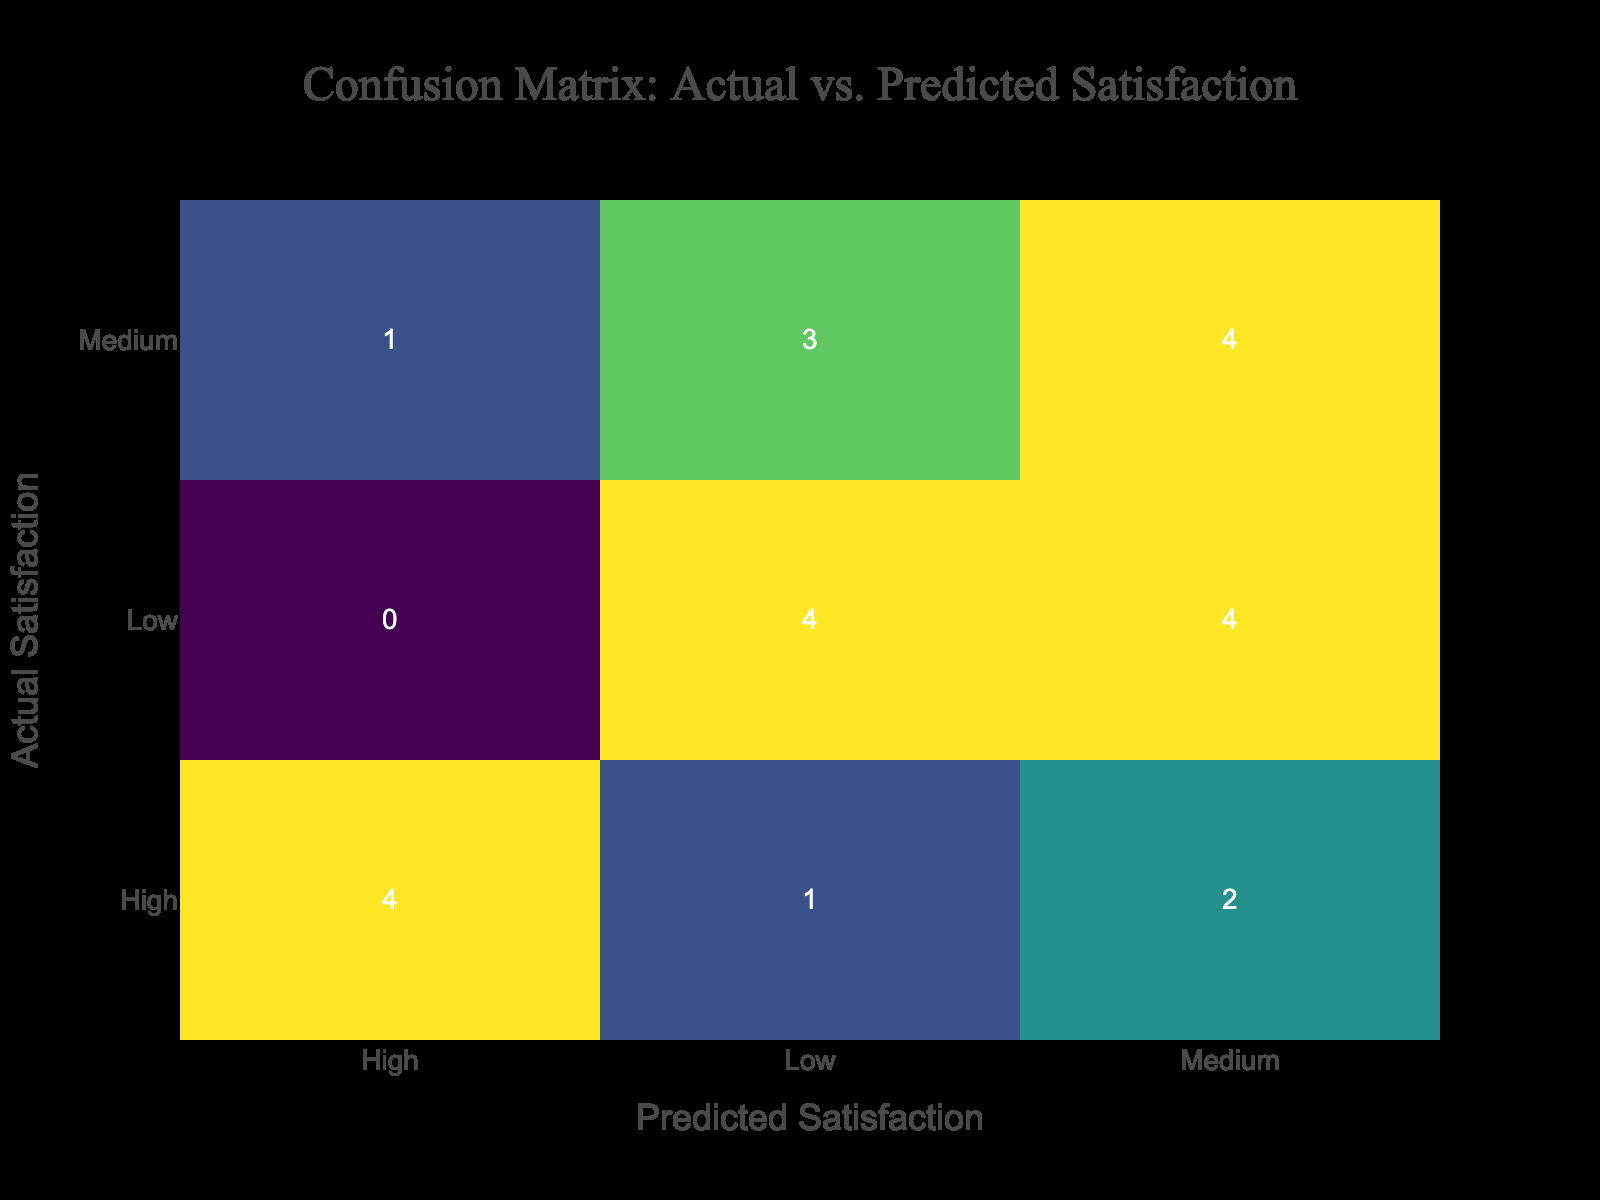What is the total number of instances where the actual satisfaction was low for the spa service? There are four recorded instances under the Spa service where the actual satisfaction was low: (Low, Low) and (Low, Medium) which appear once each in the table. Hence the total count is 2.
Answer: 2 What is the predicted satisfaction level for the majority of actual high satisfaction ratings in the concierge service? In the concierge service, out of the six instances with actual high satisfaction, four have a predicted satisfaction level of high, and two have medium. Therefore, the majority of high satisfaction ratings predicted as high is 4.
Answer: 4 Is the predicted satisfaction level higher for luxury car service compared to private chef service? Analyzing the luxury car service, the predicted levels are (High, Medium): (1, 1) and (Low, Master): (1, 1), which totals to 2 being guessed high. The private chef sees (High, High) (1), but has more with (High, Low) (1) + (Medium, Medium) (1) + (Medium, Low) (1) making three higher counts for both aspects compared to luxury car service, so it is yes that the predicted levels for luxury car service are lower overall than private chef service.
Answer: Yes What is the difference between actual high satisfaction counts for the private chef and spa services? Counting for private chef service, there are three instances where actual satisfaction is high, while for the spa service, there are two instances: meaning the difference is (3 - 2 = 1) for private chef service over spa services.
Answer: 1 Which service had the highest predicted satisfaction level and what was that level? Examining all services, the luxury car service predicted high satisfaction for 1 instance, equal to the concierge and private chef also with 1 instance each, however, the spa service ties too. All appear to have predicted high level two times therefore, every service is equal with that highest prediction level.
Answer: High 